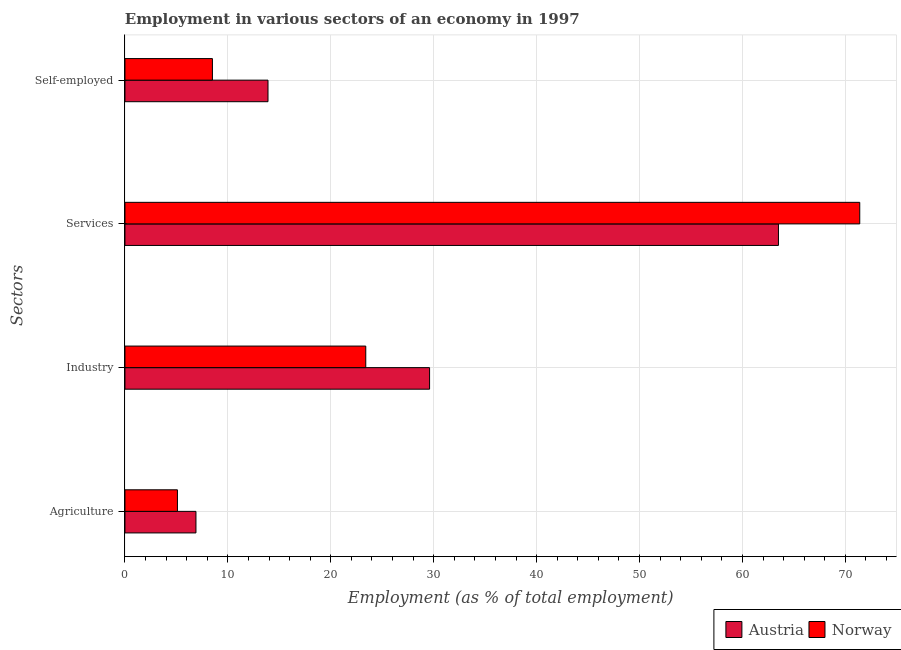Are the number of bars per tick equal to the number of legend labels?
Offer a very short reply. Yes. How many bars are there on the 2nd tick from the bottom?
Make the answer very short. 2. What is the label of the 1st group of bars from the top?
Your response must be concise. Self-employed. What is the percentage of self employed workers in Norway?
Your response must be concise. 8.5. Across all countries, what is the maximum percentage of workers in industry?
Your answer should be very brief. 29.6. Across all countries, what is the minimum percentage of workers in industry?
Offer a very short reply. 23.4. In which country was the percentage of workers in agriculture maximum?
Offer a terse response. Austria. What is the total percentage of workers in agriculture in the graph?
Provide a succinct answer. 12. What is the difference between the percentage of self employed workers in Austria and that in Norway?
Keep it short and to the point. 5.4. What is the difference between the percentage of workers in services in Austria and the percentage of self employed workers in Norway?
Offer a terse response. 55. What is the average percentage of workers in industry per country?
Your response must be concise. 26.5. What is the difference between the percentage of workers in industry and percentage of workers in agriculture in Austria?
Give a very brief answer. 22.7. What is the ratio of the percentage of workers in agriculture in Norway to that in Austria?
Keep it short and to the point. 0.74. Is the percentage of workers in industry in Norway less than that in Austria?
Keep it short and to the point. Yes. Is the difference between the percentage of workers in industry in Norway and Austria greater than the difference between the percentage of workers in agriculture in Norway and Austria?
Your response must be concise. No. What is the difference between the highest and the second highest percentage of workers in services?
Give a very brief answer. 7.9. What is the difference between the highest and the lowest percentage of workers in industry?
Your response must be concise. 6.2. Is the sum of the percentage of self employed workers in Norway and Austria greater than the maximum percentage of workers in industry across all countries?
Your answer should be compact. No. Is it the case that in every country, the sum of the percentage of self employed workers and percentage of workers in agriculture is greater than the sum of percentage of workers in services and percentage of workers in industry?
Offer a terse response. Yes. How many bars are there?
Offer a very short reply. 8. What is the difference between two consecutive major ticks on the X-axis?
Your answer should be compact. 10. Does the graph contain grids?
Keep it short and to the point. Yes. How are the legend labels stacked?
Offer a very short reply. Horizontal. What is the title of the graph?
Offer a very short reply. Employment in various sectors of an economy in 1997. Does "Europe(developing only)" appear as one of the legend labels in the graph?
Your answer should be very brief. No. What is the label or title of the X-axis?
Ensure brevity in your answer.  Employment (as % of total employment). What is the label or title of the Y-axis?
Ensure brevity in your answer.  Sectors. What is the Employment (as % of total employment) of Austria in Agriculture?
Your response must be concise. 6.9. What is the Employment (as % of total employment) in Norway in Agriculture?
Your answer should be compact. 5.1. What is the Employment (as % of total employment) in Austria in Industry?
Provide a short and direct response. 29.6. What is the Employment (as % of total employment) in Norway in Industry?
Your response must be concise. 23.4. What is the Employment (as % of total employment) of Austria in Services?
Offer a very short reply. 63.5. What is the Employment (as % of total employment) of Norway in Services?
Your answer should be compact. 71.4. What is the Employment (as % of total employment) of Austria in Self-employed?
Your response must be concise. 13.9. What is the Employment (as % of total employment) of Norway in Self-employed?
Your response must be concise. 8.5. Across all Sectors, what is the maximum Employment (as % of total employment) in Austria?
Your response must be concise. 63.5. Across all Sectors, what is the maximum Employment (as % of total employment) in Norway?
Keep it short and to the point. 71.4. Across all Sectors, what is the minimum Employment (as % of total employment) of Austria?
Your answer should be compact. 6.9. Across all Sectors, what is the minimum Employment (as % of total employment) in Norway?
Offer a very short reply. 5.1. What is the total Employment (as % of total employment) in Austria in the graph?
Your answer should be very brief. 113.9. What is the total Employment (as % of total employment) of Norway in the graph?
Give a very brief answer. 108.4. What is the difference between the Employment (as % of total employment) in Austria in Agriculture and that in Industry?
Ensure brevity in your answer.  -22.7. What is the difference between the Employment (as % of total employment) of Norway in Agriculture and that in Industry?
Give a very brief answer. -18.3. What is the difference between the Employment (as % of total employment) in Austria in Agriculture and that in Services?
Your response must be concise. -56.6. What is the difference between the Employment (as % of total employment) of Norway in Agriculture and that in Services?
Offer a terse response. -66.3. What is the difference between the Employment (as % of total employment) of Austria in Agriculture and that in Self-employed?
Offer a very short reply. -7. What is the difference between the Employment (as % of total employment) of Norway in Agriculture and that in Self-employed?
Your response must be concise. -3.4. What is the difference between the Employment (as % of total employment) of Austria in Industry and that in Services?
Offer a very short reply. -33.9. What is the difference between the Employment (as % of total employment) in Norway in Industry and that in Services?
Give a very brief answer. -48. What is the difference between the Employment (as % of total employment) in Austria in Industry and that in Self-employed?
Offer a very short reply. 15.7. What is the difference between the Employment (as % of total employment) of Norway in Industry and that in Self-employed?
Offer a very short reply. 14.9. What is the difference between the Employment (as % of total employment) of Austria in Services and that in Self-employed?
Keep it short and to the point. 49.6. What is the difference between the Employment (as % of total employment) of Norway in Services and that in Self-employed?
Your response must be concise. 62.9. What is the difference between the Employment (as % of total employment) in Austria in Agriculture and the Employment (as % of total employment) in Norway in Industry?
Offer a very short reply. -16.5. What is the difference between the Employment (as % of total employment) of Austria in Agriculture and the Employment (as % of total employment) of Norway in Services?
Your answer should be compact. -64.5. What is the difference between the Employment (as % of total employment) of Austria in Agriculture and the Employment (as % of total employment) of Norway in Self-employed?
Your answer should be very brief. -1.6. What is the difference between the Employment (as % of total employment) of Austria in Industry and the Employment (as % of total employment) of Norway in Services?
Offer a very short reply. -41.8. What is the difference between the Employment (as % of total employment) of Austria in Industry and the Employment (as % of total employment) of Norway in Self-employed?
Your response must be concise. 21.1. What is the difference between the Employment (as % of total employment) of Austria in Services and the Employment (as % of total employment) of Norway in Self-employed?
Offer a terse response. 55. What is the average Employment (as % of total employment) of Austria per Sectors?
Your answer should be compact. 28.48. What is the average Employment (as % of total employment) of Norway per Sectors?
Ensure brevity in your answer.  27.1. What is the difference between the Employment (as % of total employment) of Austria and Employment (as % of total employment) of Norway in Services?
Ensure brevity in your answer.  -7.9. What is the ratio of the Employment (as % of total employment) of Austria in Agriculture to that in Industry?
Your answer should be very brief. 0.23. What is the ratio of the Employment (as % of total employment) in Norway in Agriculture to that in Industry?
Make the answer very short. 0.22. What is the ratio of the Employment (as % of total employment) of Austria in Agriculture to that in Services?
Provide a succinct answer. 0.11. What is the ratio of the Employment (as % of total employment) in Norway in Agriculture to that in Services?
Your answer should be very brief. 0.07. What is the ratio of the Employment (as % of total employment) in Austria in Agriculture to that in Self-employed?
Your answer should be very brief. 0.5. What is the ratio of the Employment (as % of total employment) of Austria in Industry to that in Services?
Keep it short and to the point. 0.47. What is the ratio of the Employment (as % of total employment) of Norway in Industry to that in Services?
Provide a short and direct response. 0.33. What is the ratio of the Employment (as % of total employment) in Austria in Industry to that in Self-employed?
Provide a short and direct response. 2.13. What is the ratio of the Employment (as % of total employment) of Norway in Industry to that in Self-employed?
Keep it short and to the point. 2.75. What is the ratio of the Employment (as % of total employment) in Austria in Services to that in Self-employed?
Ensure brevity in your answer.  4.57. What is the ratio of the Employment (as % of total employment) in Norway in Services to that in Self-employed?
Give a very brief answer. 8.4. What is the difference between the highest and the second highest Employment (as % of total employment) in Austria?
Keep it short and to the point. 33.9. What is the difference between the highest and the lowest Employment (as % of total employment) in Austria?
Your response must be concise. 56.6. What is the difference between the highest and the lowest Employment (as % of total employment) in Norway?
Make the answer very short. 66.3. 